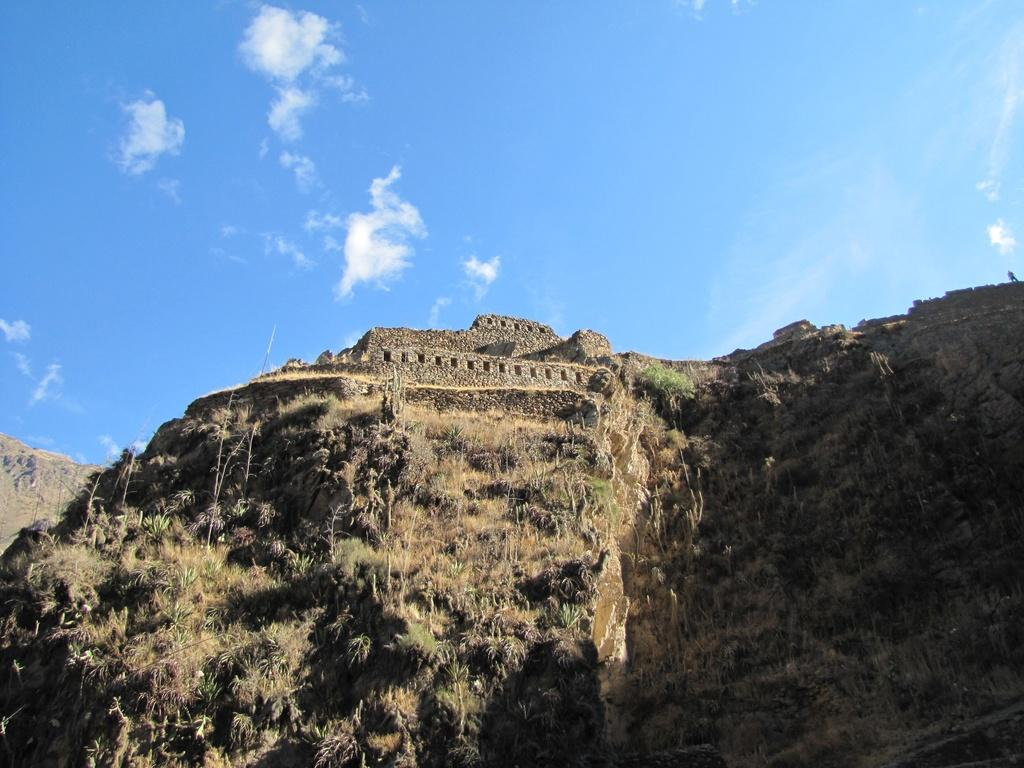What type of natural landform is visible in the image? There is a mountain in the image. What type of vegetation can be seen in the image? There are trees in the image. What is visible at the top of the image? The sky is visible at the top of the image. What can be seen in the sky in the image? Clouds are present in the sky. Where is the store located in the image? There is no store present in the image; it features a mountain, trees, and a sky with clouds. What type of animals can be seen interacting with the trees in the image? There are no animals present in the image; it only features a mountain, trees, and a sky with clouds. 